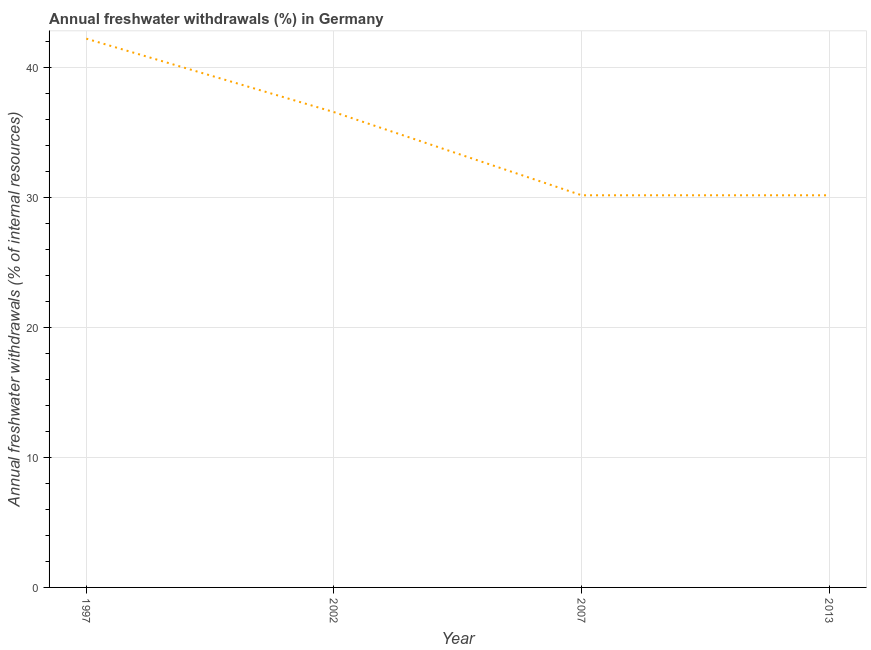What is the annual freshwater withdrawals in 2013?
Keep it short and to the point. 30.19. Across all years, what is the maximum annual freshwater withdrawals?
Your response must be concise. 42.24. Across all years, what is the minimum annual freshwater withdrawals?
Ensure brevity in your answer.  30.19. In which year was the annual freshwater withdrawals maximum?
Your answer should be very brief. 1997. What is the sum of the annual freshwater withdrawals?
Provide a succinct answer. 139.21. What is the difference between the annual freshwater withdrawals in 1997 and 2002?
Make the answer very short. 5.65. What is the average annual freshwater withdrawals per year?
Provide a short and direct response. 34.8. What is the median annual freshwater withdrawals?
Provide a succinct answer. 33.39. In how many years, is the annual freshwater withdrawals greater than 24 %?
Your response must be concise. 4. What is the ratio of the annual freshwater withdrawals in 2007 to that in 2013?
Provide a succinct answer. 1. Is the annual freshwater withdrawals in 2002 less than that in 2007?
Give a very brief answer. No. What is the difference between the highest and the second highest annual freshwater withdrawals?
Your response must be concise. 5.65. Is the sum of the annual freshwater withdrawals in 1997 and 2013 greater than the maximum annual freshwater withdrawals across all years?
Provide a short and direct response. Yes. What is the difference between the highest and the lowest annual freshwater withdrawals?
Offer a very short reply. 12.06. How many lines are there?
Keep it short and to the point. 1. How many years are there in the graph?
Offer a very short reply. 4. Are the values on the major ticks of Y-axis written in scientific E-notation?
Ensure brevity in your answer.  No. Does the graph contain any zero values?
Ensure brevity in your answer.  No. What is the title of the graph?
Make the answer very short. Annual freshwater withdrawals (%) in Germany. What is the label or title of the Y-axis?
Offer a terse response. Annual freshwater withdrawals (% of internal resources). What is the Annual freshwater withdrawals (% of internal resources) of 1997?
Your response must be concise. 42.24. What is the Annual freshwater withdrawals (% of internal resources) of 2002?
Provide a short and direct response. 36.59. What is the Annual freshwater withdrawals (% of internal resources) of 2007?
Your answer should be very brief. 30.19. What is the Annual freshwater withdrawals (% of internal resources) of 2013?
Make the answer very short. 30.19. What is the difference between the Annual freshwater withdrawals (% of internal resources) in 1997 and 2002?
Make the answer very short. 5.65. What is the difference between the Annual freshwater withdrawals (% of internal resources) in 1997 and 2007?
Offer a very short reply. 12.06. What is the difference between the Annual freshwater withdrawals (% of internal resources) in 1997 and 2013?
Your answer should be very brief. 12.06. What is the difference between the Annual freshwater withdrawals (% of internal resources) in 2002 and 2007?
Your response must be concise. 6.4. What is the difference between the Annual freshwater withdrawals (% of internal resources) in 2002 and 2013?
Keep it short and to the point. 6.4. What is the difference between the Annual freshwater withdrawals (% of internal resources) in 2007 and 2013?
Provide a succinct answer. 0. What is the ratio of the Annual freshwater withdrawals (% of internal resources) in 1997 to that in 2002?
Keep it short and to the point. 1.16. What is the ratio of the Annual freshwater withdrawals (% of internal resources) in 1997 to that in 2007?
Keep it short and to the point. 1.4. What is the ratio of the Annual freshwater withdrawals (% of internal resources) in 1997 to that in 2013?
Ensure brevity in your answer.  1.4. What is the ratio of the Annual freshwater withdrawals (% of internal resources) in 2002 to that in 2007?
Your response must be concise. 1.21. What is the ratio of the Annual freshwater withdrawals (% of internal resources) in 2002 to that in 2013?
Make the answer very short. 1.21. What is the ratio of the Annual freshwater withdrawals (% of internal resources) in 2007 to that in 2013?
Provide a short and direct response. 1. 